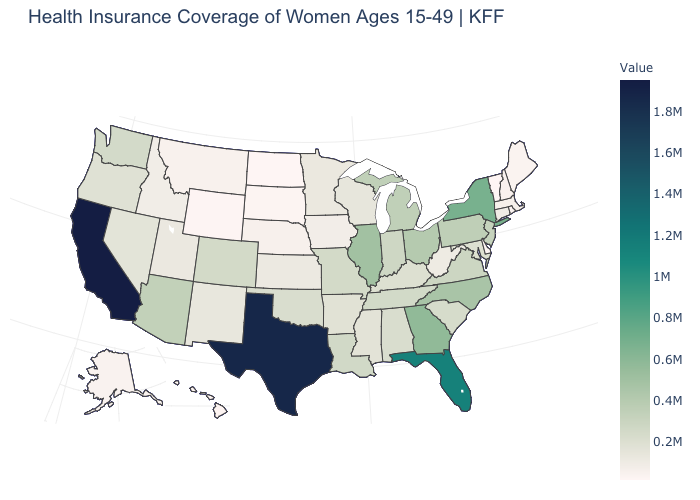Does Vermont have the lowest value in the USA?
Answer briefly. Yes. Does the map have missing data?
Answer briefly. No. Among the states that border New Mexico , does Texas have the highest value?
Answer briefly. Yes. Which states have the lowest value in the USA?
Answer briefly. Vermont. Which states have the lowest value in the Northeast?
Answer briefly. Vermont. Which states have the highest value in the USA?
Be succinct. California. Among the states that border Colorado , which have the highest value?
Be succinct. Arizona. Which states have the highest value in the USA?
Write a very short answer. California. 